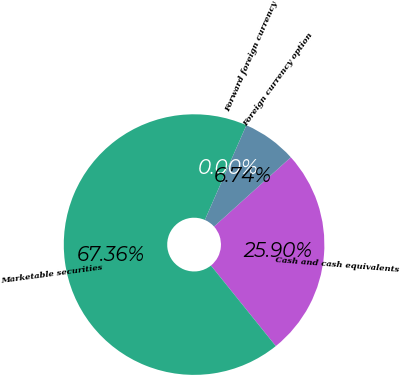Convert chart to OTSL. <chart><loc_0><loc_0><loc_500><loc_500><pie_chart><fcel>Cash and cash equivalents<fcel>Marketable securities<fcel>Forward foreign currency<fcel>Foreign currency option<nl><fcel>25.9%<fcel>67.36%<fcel>0.0%<fcel>6.74%<nl></chart> 